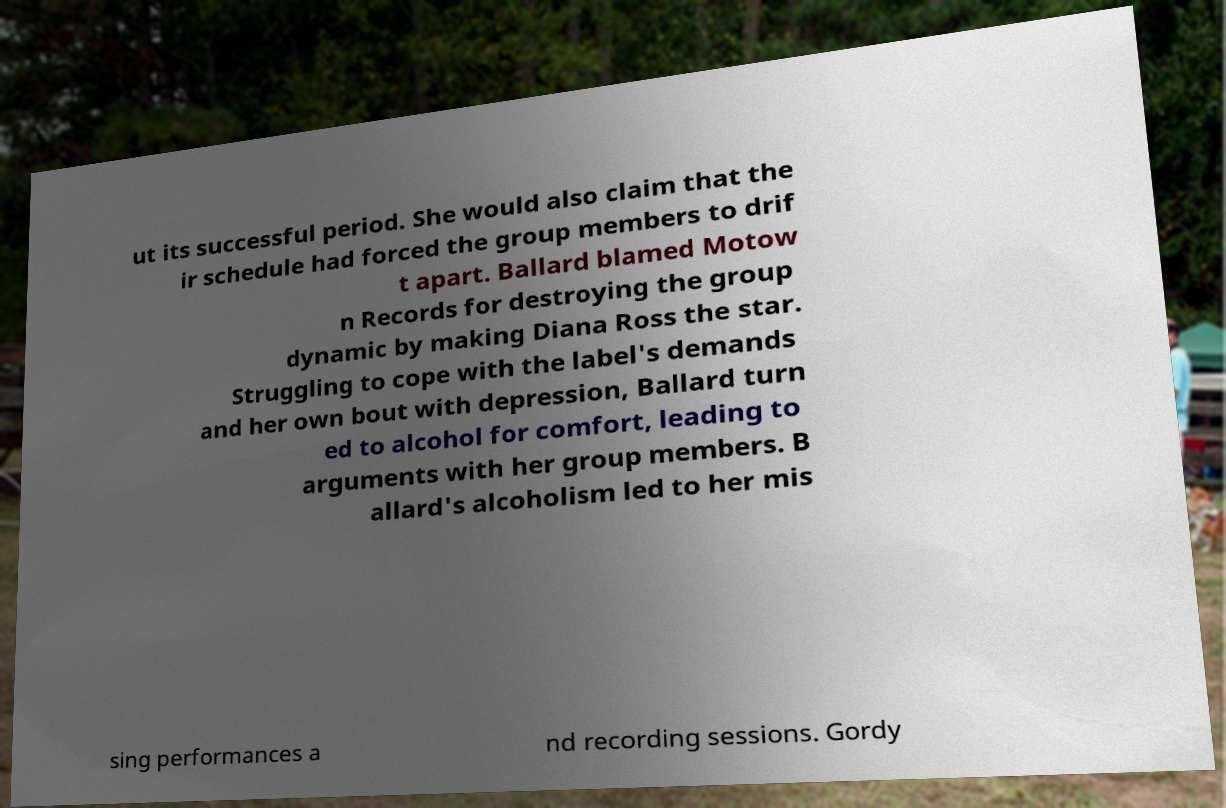Please identify and transcribe the text found in this image. ut its successful period. She would also claim that the ir schedule had forced the group members to drif t apart. Ballard blamed Motow n Records for destroying the group dynamic by making Diana Ross the star. Struggling to cope with the label's demands and her own bout with depression, Ballard turn ed to alcohol for comfort, leading to arguments with her group members. B allard's alcoholism led to her mis sing performances a nd recording sessions. Gordy 